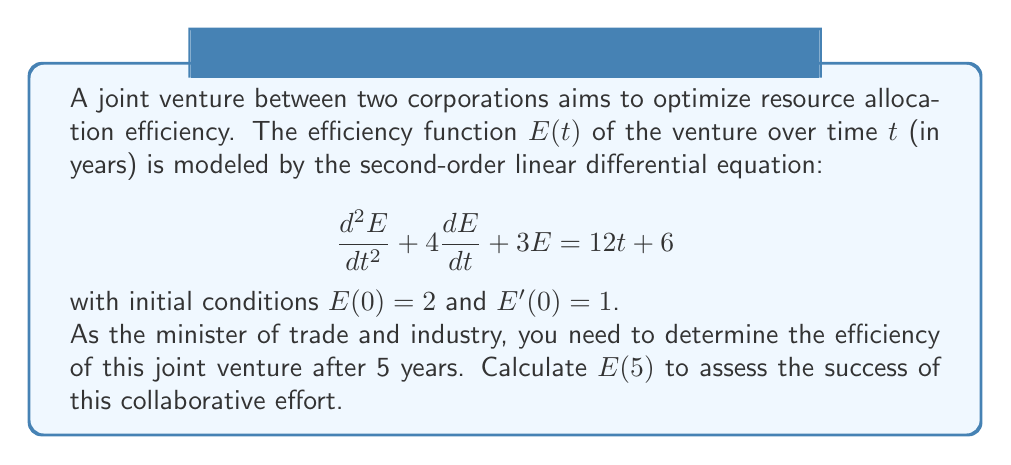Could you help me with this problem? To solve this problem, we need to follow these steps:

1) First, we need to find the general solution of the homogeneous equation:
   $$\frac{d^2E}{dt^2} + 4\frac{dE}{dt} + 3E = 0$$

   The characteristic equation is $r^2 + 4r + 3 = 0$
   Solving this, we get $r = -1$ or $r = -3$
   So, the homogeneous solution is $E_h(t) = c_1e^{-t} + c_2e^{-3t}$

2) Next, we find a particular solution for the non-homogeneous equation:
   Let $E_p(t) = At + B$ (since the right side is linear in t)
   Substituting this into the original equation:
   $0 + 4A + 3(At + B) = 12t + 6$
   Equating coefficients: $3A = 12$, so $A = 4$
   And $4A + 3B = 6$, so $3B = -10$, and $B = -\frac{10}{3}$
   Therefore, $E_p(t) = 4t - \frac{10}{3}$

3) The general solution is $E(t) = E_h(t) + E_p(t) = c_1e^{-t} + c_2e^{-3t} + 4t - \frac{10}{3}$

4) Now we use the initial conditions to find $c_1$ and $c_2$:
   $E(0) = 2$, so $c_1 + c_2 - \frac{10}{3} = 2$
   $E'(0) = 1$, so $-c_1 - 3c_2 + 4 = 1$

   Solving these equations:
   $c_1 = \frac{16}{3}$, $c_2 = -\frac{4}{3}$

5) Therefore, the particular solution is:
   $$E(t) = \frac{16}{3}e^{-t} - \frac{4}{3}e^{-3t} + 4t - \frac{10}{3}$$

6) To find $E(5)$, we simply substitute $t = 5$:
   $$E(5) = \frac{16}{3}e^{-5} - \frac{4}{3}e^{-15} + 4(5) - \frac{10}{3}$$
Answer: $$E(5) \approx 18.11$$
The efficiency of the joint venture after 5 years is approximately 18.11 units. 